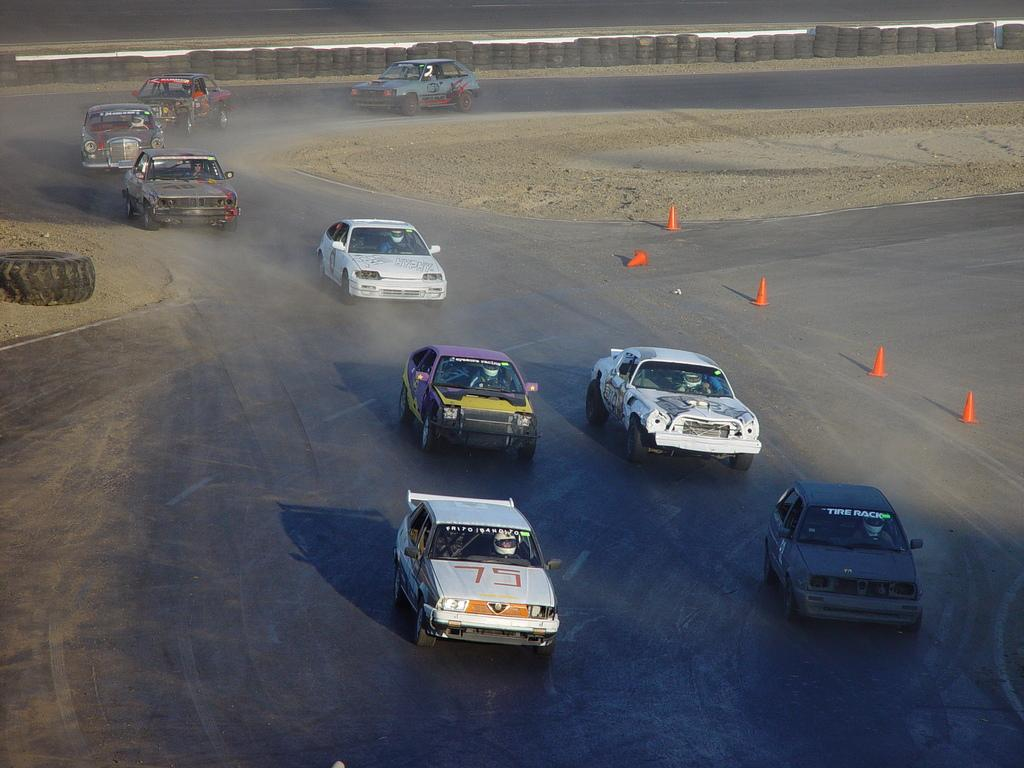What can be seen on the road in the image? There are cars on the road in the image. Where are the cars located in the image? The cars are in the middle of the image. What part of the cars is visible in the image? Tyres are visible in the image. Can you describe the position of some tyres in the image? Some tyres are at the top of the image, and one tyre is on the left side of the image. How many cows are grazing on the side of the road in the image? There are no cows present in the image; it only features cars and tyres. What type of business is being conducted in the image? There is no business activity depicted in the image; it focuses on cars and tyres on the road. 